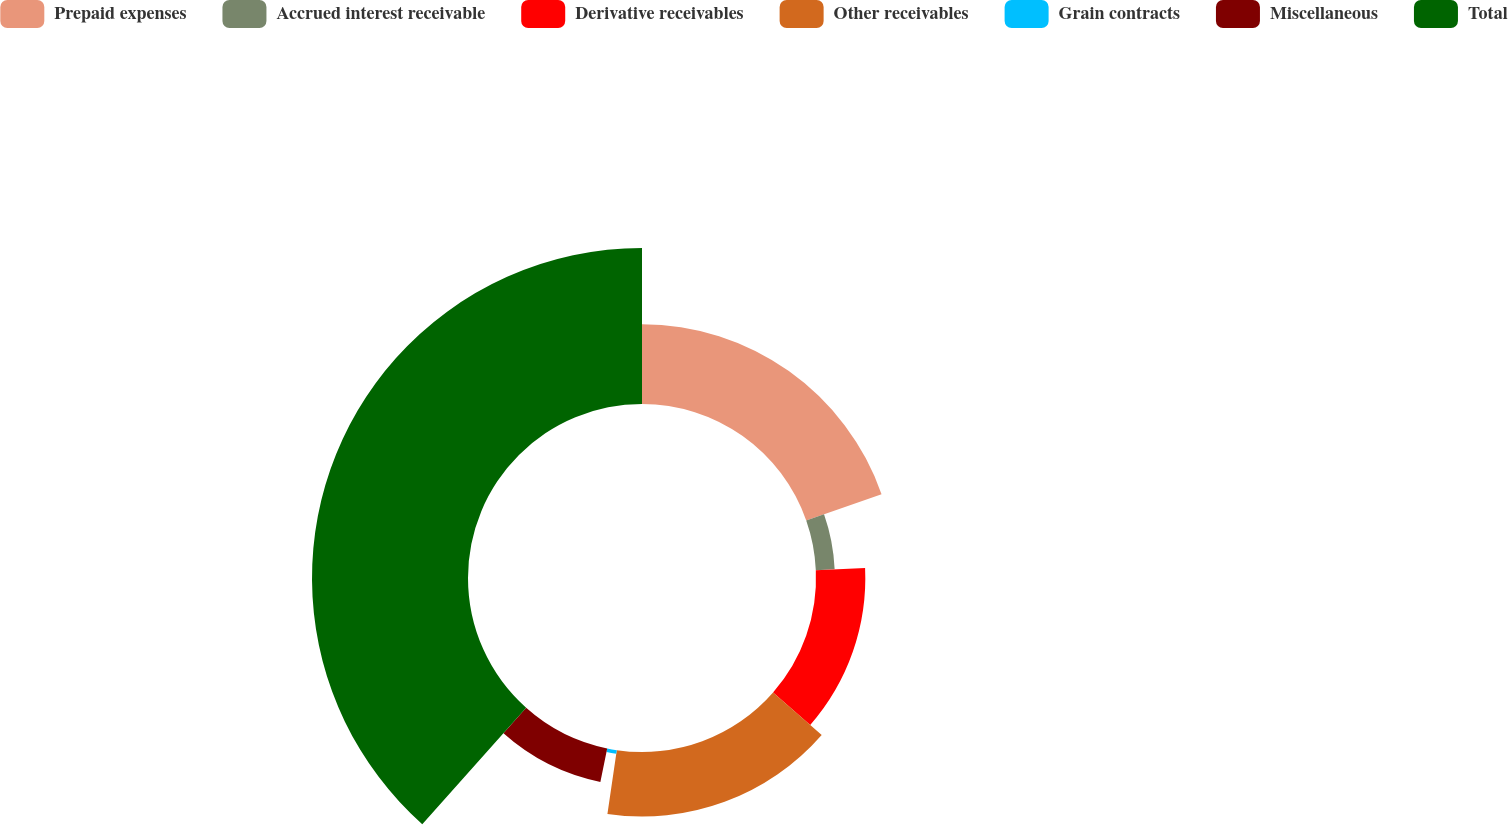Convert chart. <chart><loc_0><loc_0><loc_500><loc_500><pie_chart><fcel>Prepaid expenses<fcel>Accrued interest receivable<fcel>Derivative receivables<fcel>Other receivables<fcel>Grain contracts<fcel>Miscellaneous<fcel>Total<nl><fcel>19.64%<fcel>4.64%<fcel>12.14%<fcel>15.89%<fcel>0.89%<fcel>8.39%<fcel>38.4%<nl></chart> 